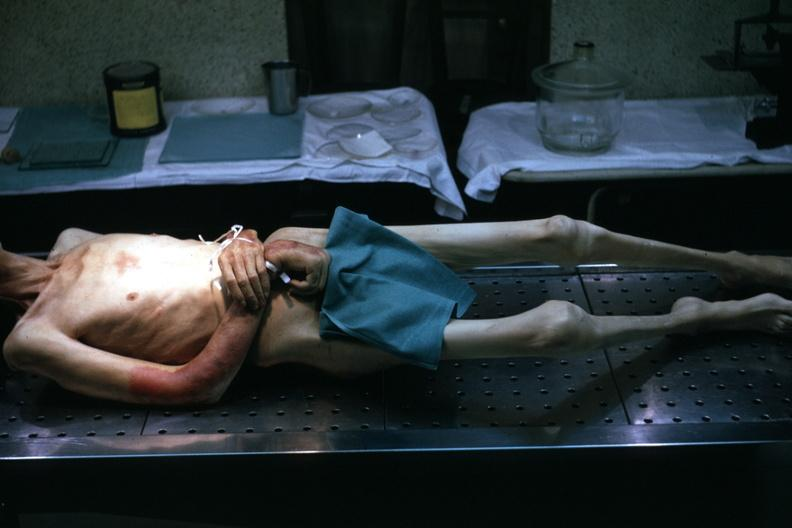does this image show good example tastefully shown with face out of picture and genitalia covered muscle atrophy is striking?
Answer the question using a single word or phrase. Yes 